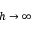Convert formula to latex. <formula><loc_0><loc_0><loc_500><loc_500>h \to \infty</formula> 